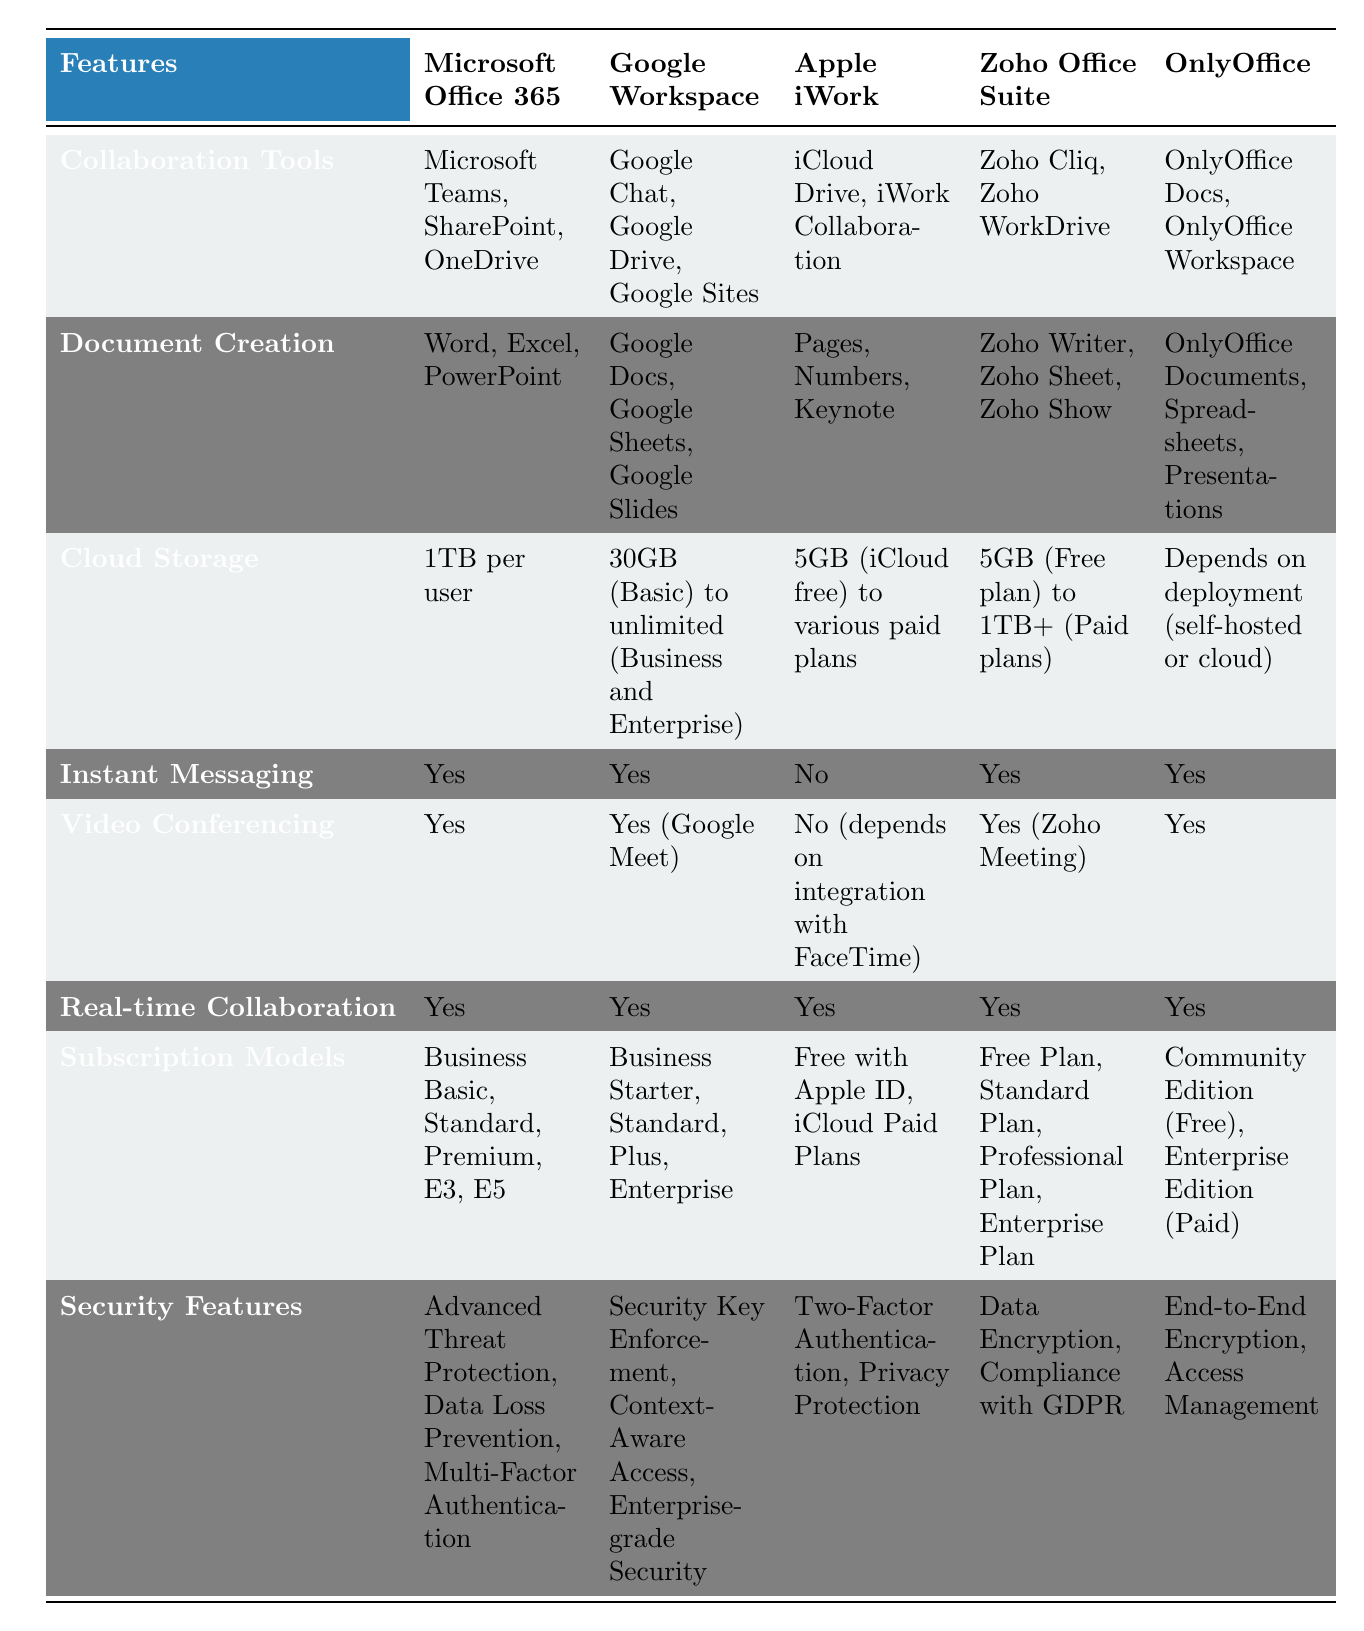What collaboration tools does Microsoft Office 365 offer? The table indicates that Microsoft Office 365 includes collaboration tools such as Microsoft Teams, SharePoint, and OneDrive.
Answer: Microsoft Teams, SharePoint, OneDrive Which feature does Apple iWork lack when compared to other services? Apple iWork does not include instant messaging or video conferencing features, as indicated in the table.
Answer: Instant messaging and video conferencing What is the maximum cloud storage offered by Google Workspace? The table shows that Google Workspace offers up to unlimited cloud storage for Business and Enterprise customers.
Answer: Unlimited Does OnlyOffice provide instant messaging as a feature? According to the table, OnlyOffice does provide instant messaging, so the answer is yes.
Answer: Yes What are the different subscription models available for Zoho Office Suite? The table lists the subscription models for Zoho Office Suite as Free Plan, Standard Plan, Professional Plan, and Enterprise Plan.
Answer: Free Plan, Standard Plan, Professional Plan, Enterprise Plan How does the cloud storage of Microsoft Office 365 compare to that of Apple iWork? Microsoft Office 365 offers 1TB per user, while Apple iWork ranges from 5GB (free) to paid plans. Thus, Microsoft Office 365 offers significantly more storage on average compared to Apple iWork.
Answer: Microsoft Office 365 has more storage Which service has the strongest security features? Comparing the security features, Microsoft Office 365 offers Advanced Threat Protection, Data Loss Prevention, and Multi-Factor Authentication, while Google Workspace has Security Key Enforcement, Context-Aware Access, and Enterprise-grade Security. Each service has a unique set, but Microsoft Office 365's offerings are typically viewed as more comprehensive for enterprise use.
Answer: Microsoft Office 365's features are more comprehensive What is the average number of collaboration tools offered across the services listed? The number of collaboration tools is as follows: Microsoft Office 365 (3), Google Workspace (3), Apple iWork (2), Zoho Office Suite (2), OnlyOffice (2). Adding these gives us 3 + 3 + 2 + 2 + 2 = 12. Dividing by the number of services (5) gives us an average of 12/5 = 2.4.
Answer: 2.4 Is real-time collaboration a feature offered by all services listed? The table indicates that all services, including Microsoft Office 365, Google Workspace, Apple iWork, Zoho Office Suite, and OnlyOffice, offer real-time collaboration.
Answer: Yes How many services offer video conferencing capabilities? From the table, Microsoft Office 365, Google Workspace, Zoho Office Suite, and OnlyOffice offer video conferencing, totaling four services.
Answer: Four services 